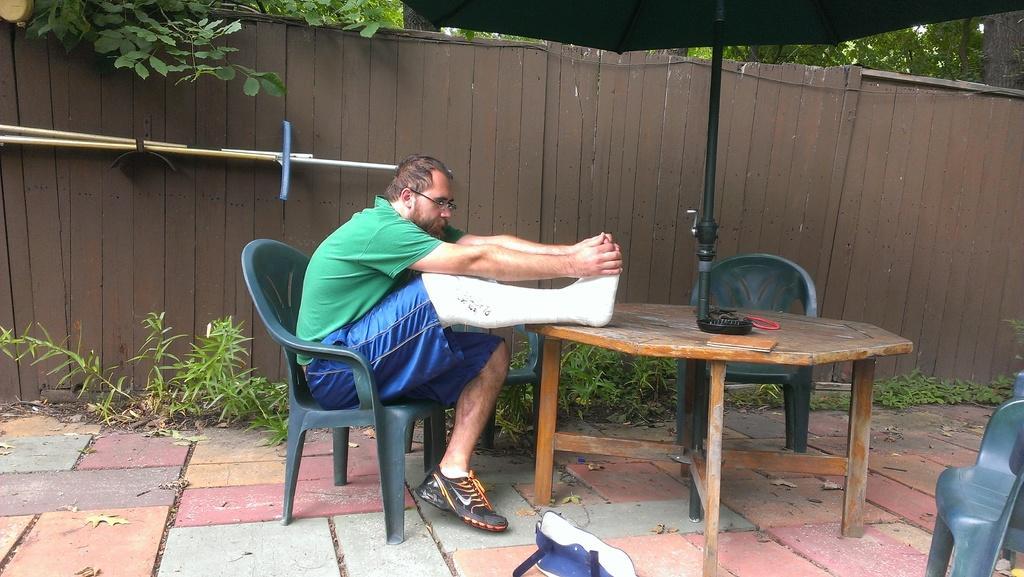Could you give a brief overview of what you see in this image? A man is stretching his broken leg by placing it on a table in front of him. 